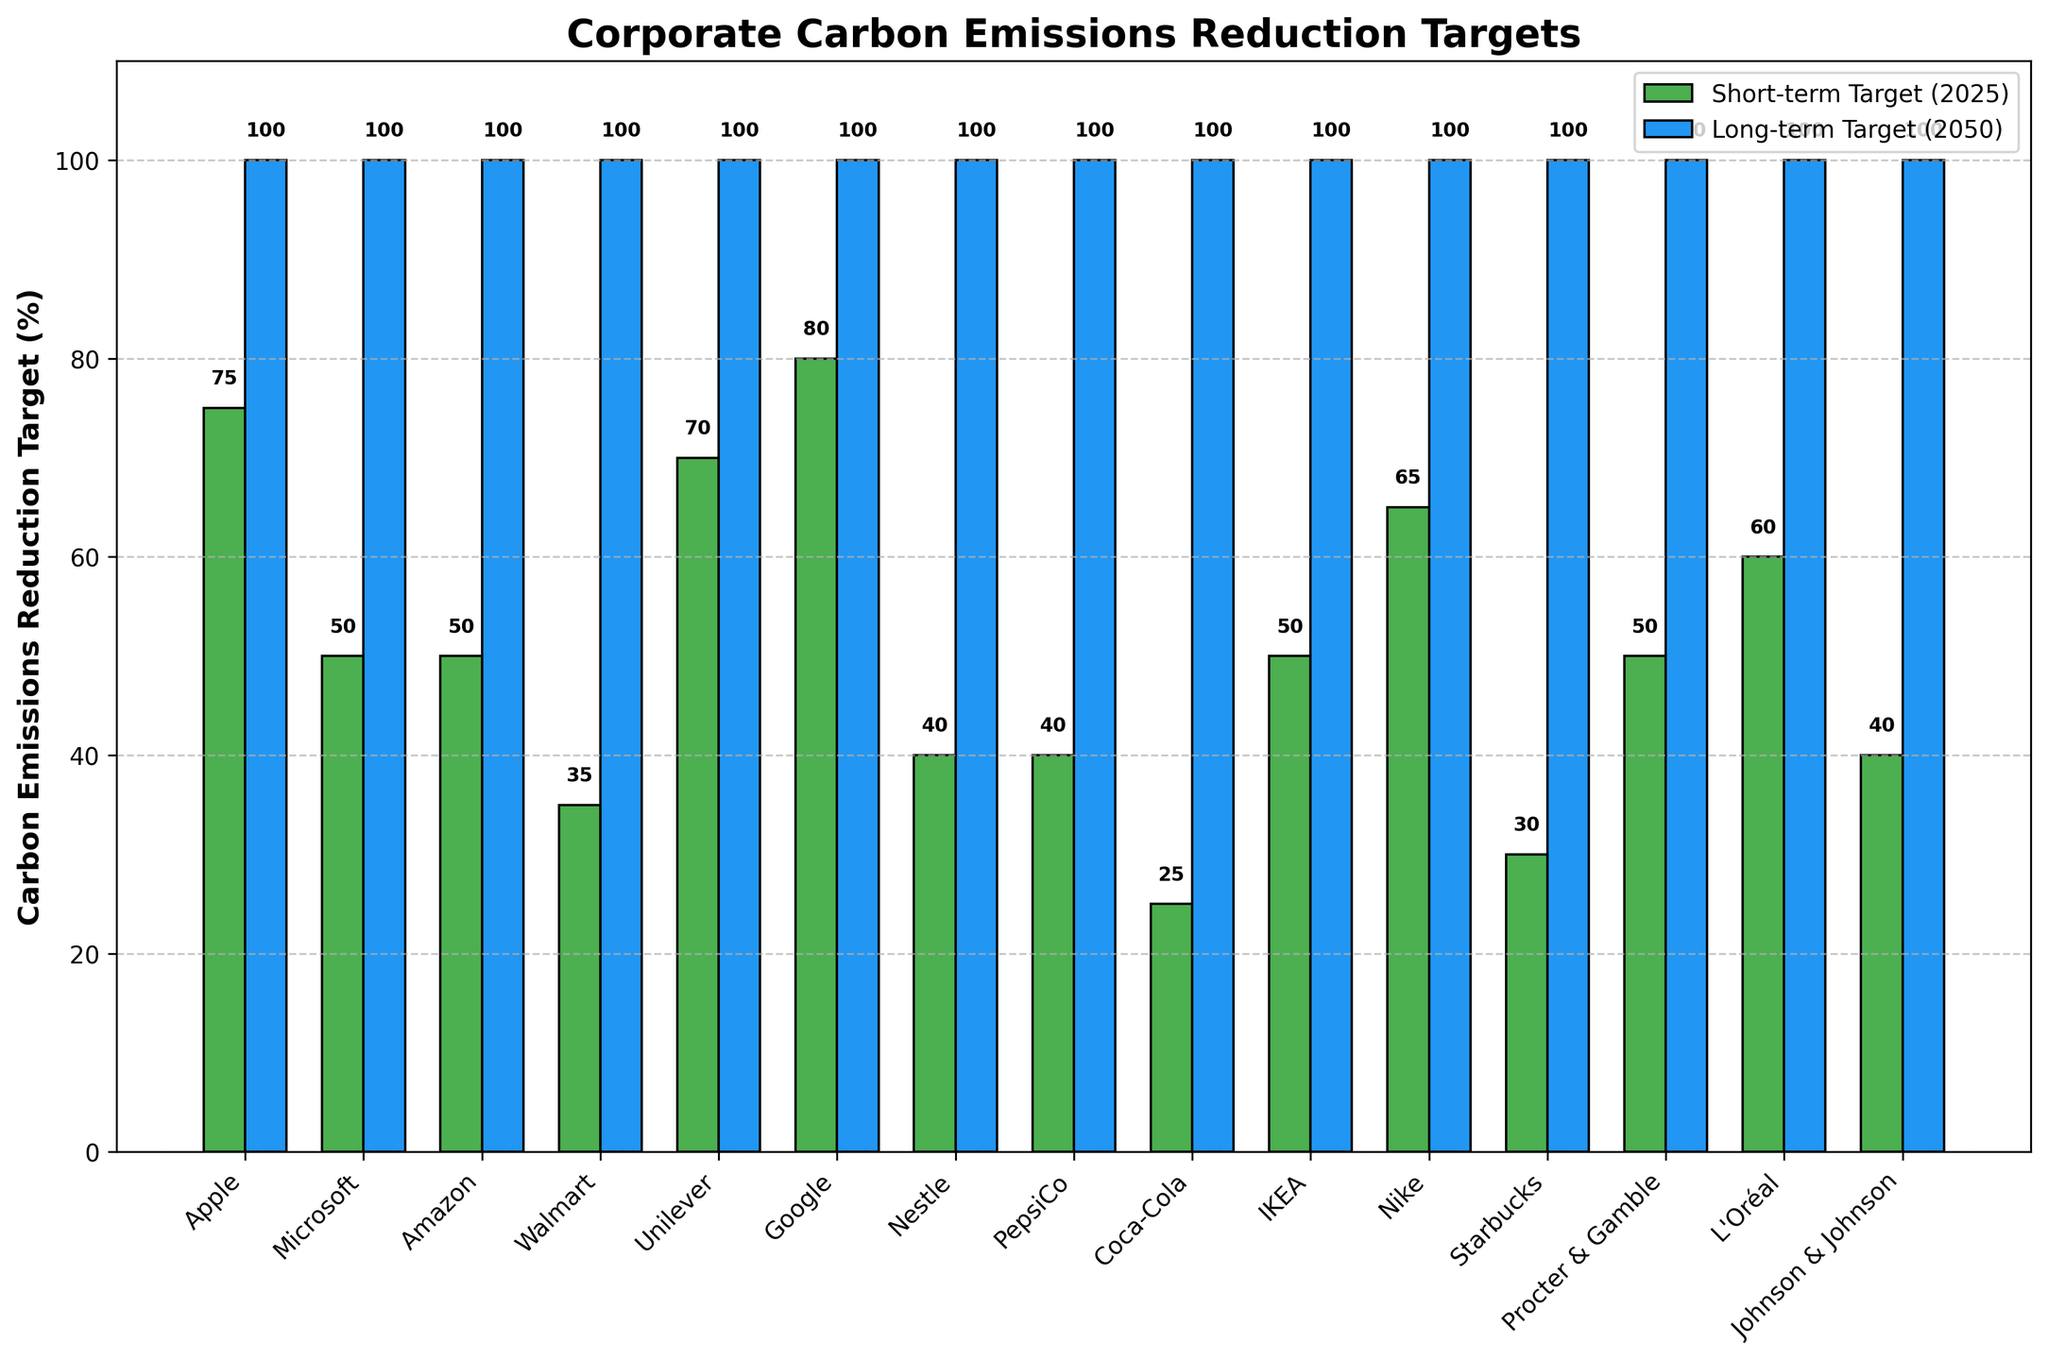Which company has the highest short-term target for carbon emissions reduction by 2025? Apple and Google both have the highest short-term target at 80%.
Answer: Apple, Google Which company has the lowest long-term target for carbon emissions reduction by 2050? All companies have a long-term target of 100%, so none have a lower target.
Answer: None What is the difference in the short-term targets between Walmart and Nike? Walmart's short-term target is 35%, and Nike's short-term target is 65%. The difference is 65% - 35% = 30%.
Answer: 30% Which company has the closest short-term target to 50%? Multiple companies have a short-term target of 50%, including Microsoft, Amazon, IKEA, and Procter & Gamble.
Answer: Microsoft, Amazon, IKEA, Procter & Gamble What is the average short-term target for all the companies? The short-term targets are: 75, 50, 50, 35, 70, 80, 40, 40, 25, 50, 65, 30, 50, 60, 40. Adding these gives a total of 760. There are 15 companies, so the average is 760 / 15 = 50.67%.
Answer: 50.67% How many companies have short-term targets of 50% or below? The companies with short-term targets of 50% or below are Microsoft, Amazon, Walmart, Nestle, PepsiCo, Coca-Cola, IKEA, Starbucks, Procter & Gamble, and Johnson & Johnson. This count is 10.
Answer: 10 Which company's short-term target is exactly twice that of PepsiCo's short-term target? PepsiCo's short-term target is 40%. Apple, with a short-term target of 80%, is exactly twice that of PepsiCo's target.
Answer: Apple What's the difference between the highest and the lowest short-term targets? The highest short-term target is Apple's and Google's 80%, while the lowest is Coca-Cola's 25%. The difference is 80% - 25% = 55%.
Answer: 55% What is the median short-term target? Sorting the short-term targets: 25, 30, 35, 40, 40, 40, 50, 50, 50, 50, 60, 65, 70, 75, 80. The median is the 8th value in this ordered list, which is 50%.
Answer: 50% How many companies have a short-term target above the median short-term target? The median short-term target is 50%. The companies above the median are Apple, Unilever, Google, Nike, and L'Oréal, making the count 5.
Answer: 5 